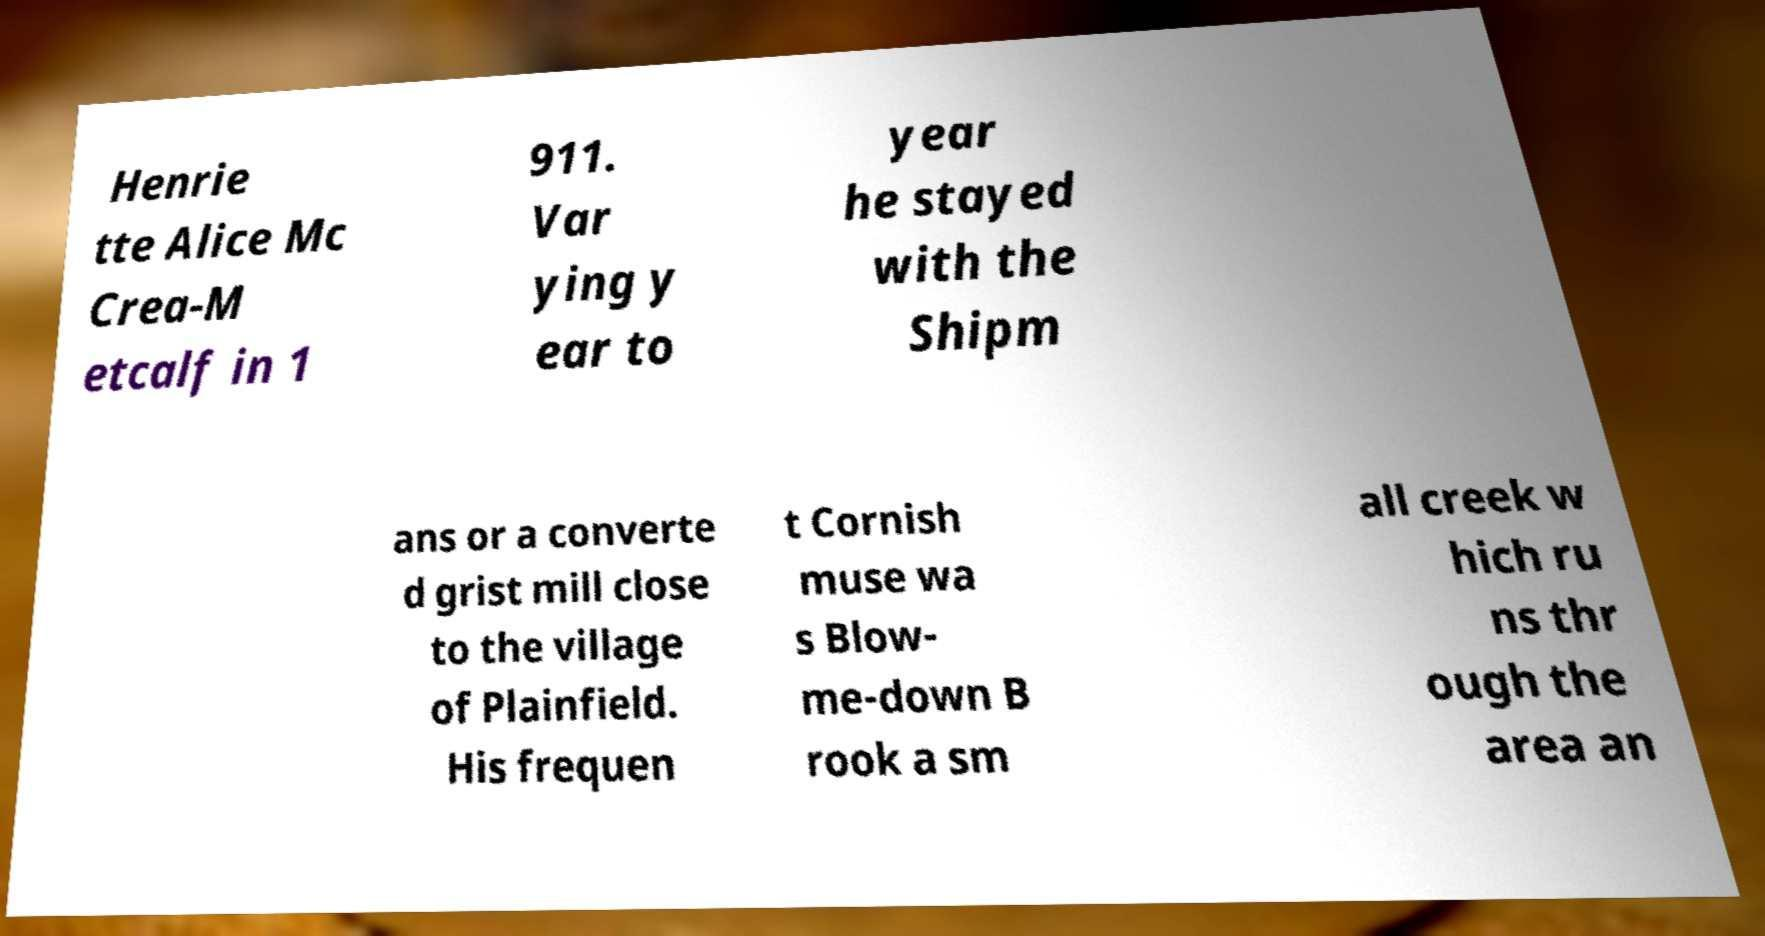There's text embedded in this image that I need extracted. Can you transcribe it verbatim? Henrie tte Alice Mc Crea-M etcalf in 1 911. Var ying y ear to year he stayed with the Shipm ans or a converte d grist mill close to the village of Plainfield. His frequen t Cornish muse wa s Blow- me-down B rook a sm all creek w hich ru ns thr ough the area an 